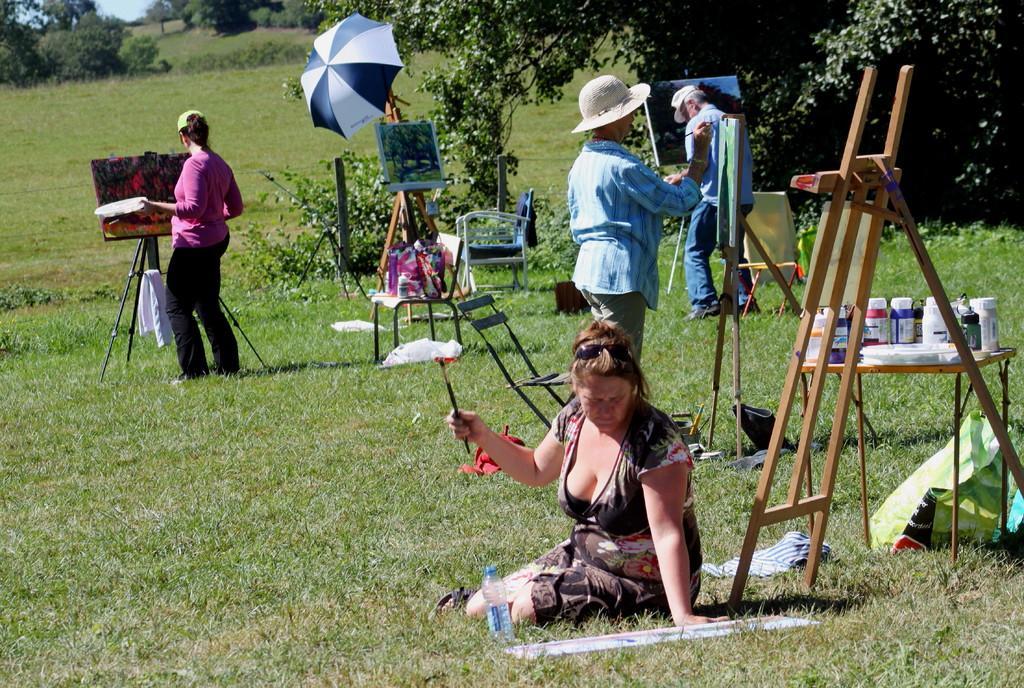Describe this image in one or two sentences. In this picture we can see some people are standing on the grass and painting on the boards, one woman is sitting on the grass and painting on the board, side we can see the tables on which we can see some bottles, around we can see some trees. 